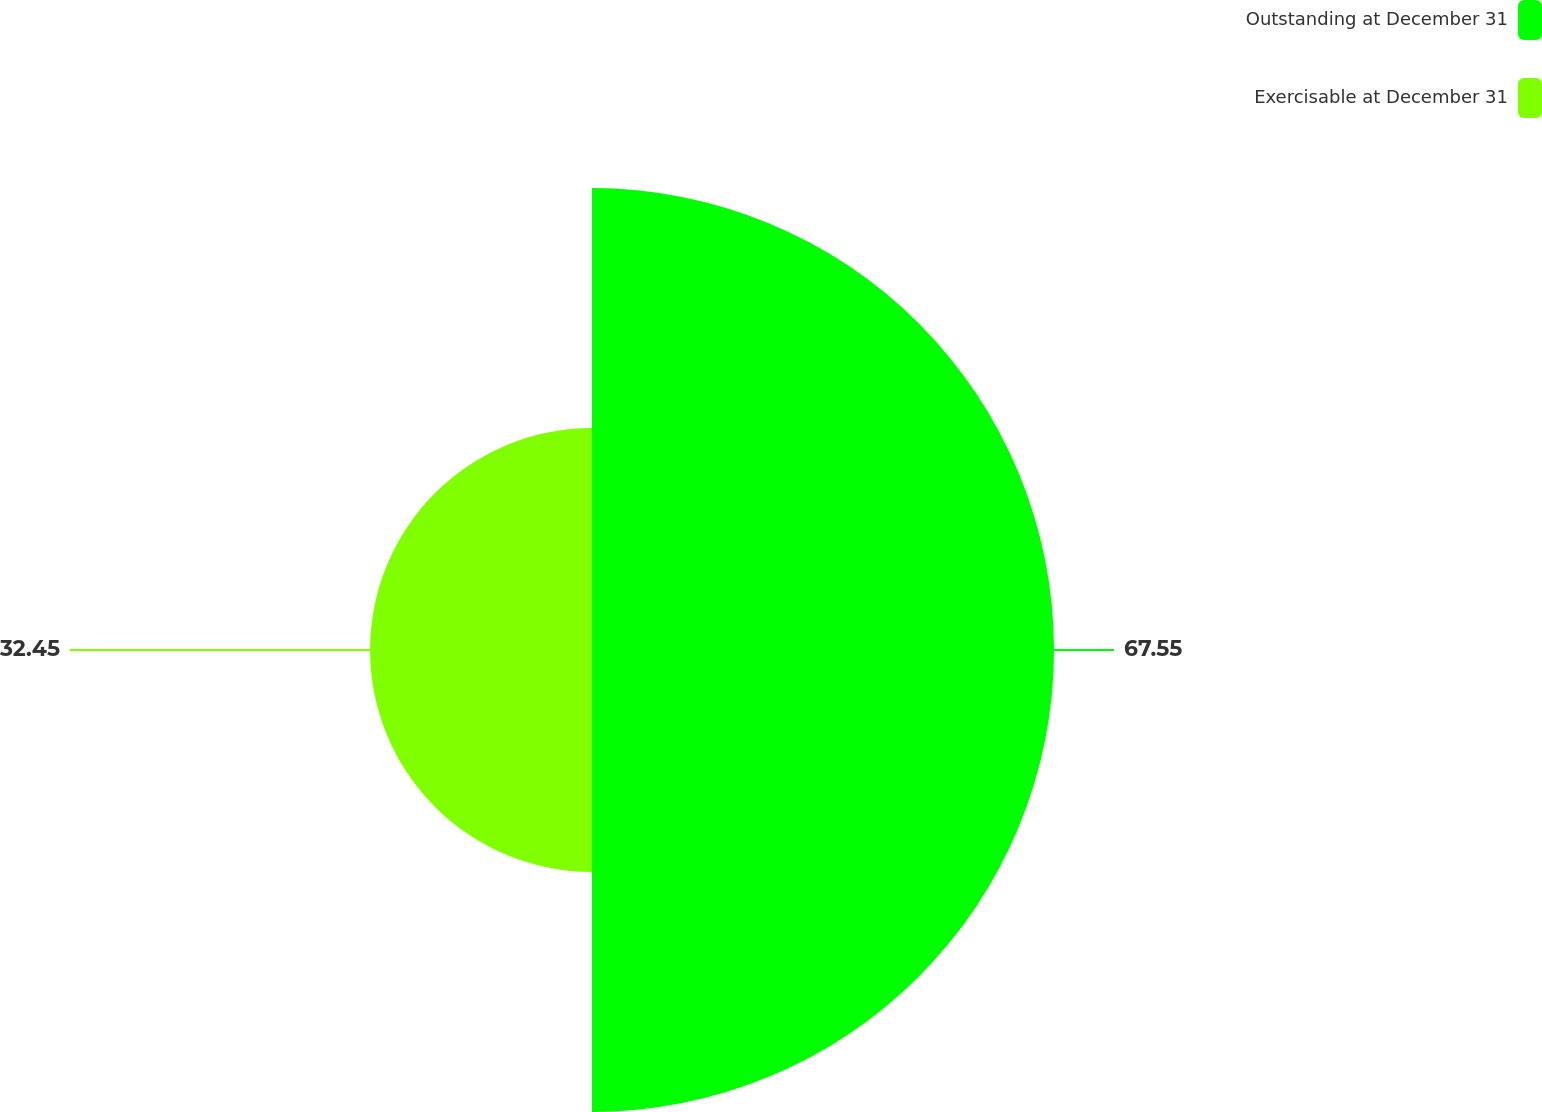Convert chart. <chart><loc_0><loc_0><loc_500><loc_500><pie_chart><fcel>Outstanding at December 31<fcel>Exercisable at December 31<nl><fcel>67.55%<fcel>32.45%<nl></chart> 